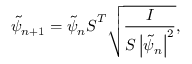<formula> <loc_0><loc_0><loc_500><loc_500>\tilde { \psi } _ { n + 1 } = \tilde { \psi } _ { n } S ^ { T } \sqrt { \frac { I } { S \left | \tilde { \psi } _ { n } \right | ^ { 2 } } } ,</formula> 